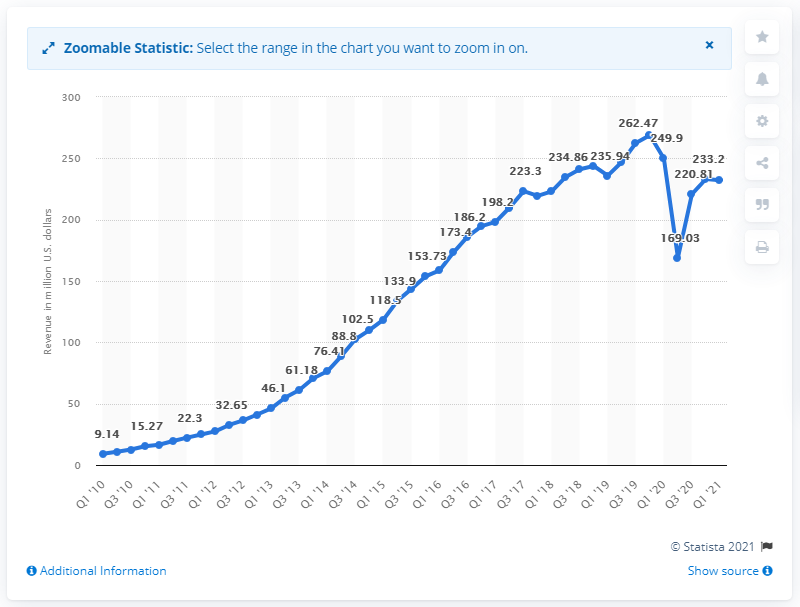Specify some key components in this picture. Yelp's revenue in the first quarter of 2021 was 232.1 million dollars. Yelp's revenue in the first quarter of 2021 was $249.9 million. 